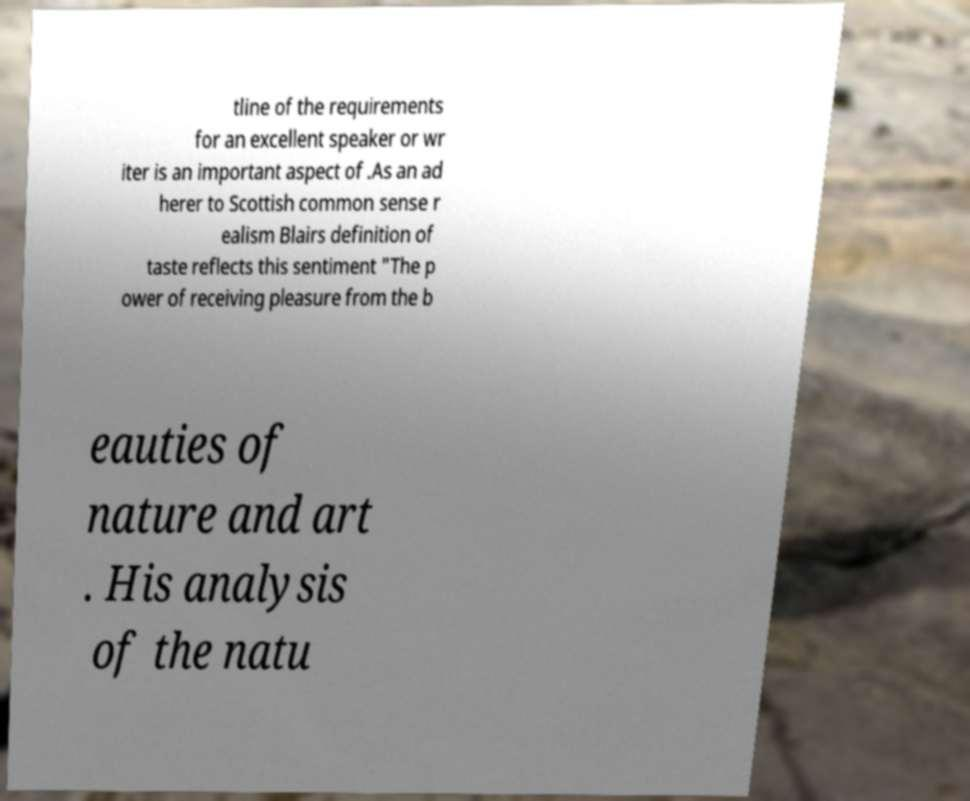Please read and relay the text visible in this image. What does it say? tline of the requirements for an excellent speaker or wr iter is an important aspect of .As an ad herer to Scottish common sense r ealism Blairs definition of taste reflects this sentiment "The p ower of receiving pleasure from the b eauties of nature and art . His analysis of the natu 